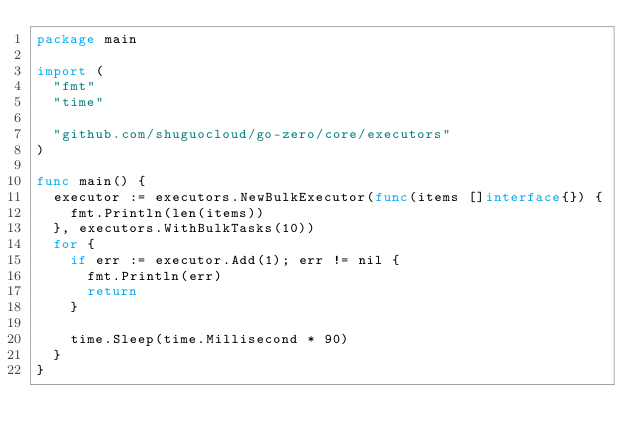<code> <loc_0><loc_0><loc_500><loc_500><_Go_>package main

import (
	"fmt"
	"time"

	"github.com/shuguocloud/go-zero/core/executors"
)

func main() {
	executor := executors.NewBulkExecutor(func(items []interface{}) {
		fmt.Println(len(items))
	}, executors.WithBulkTasks(10))
	for {
		if err := executor.Add(1); err != nil {
			fmt.Println(err)
			return
		}

		time.Sleep(time.Millisecond * 90)
	}
}
</code> 